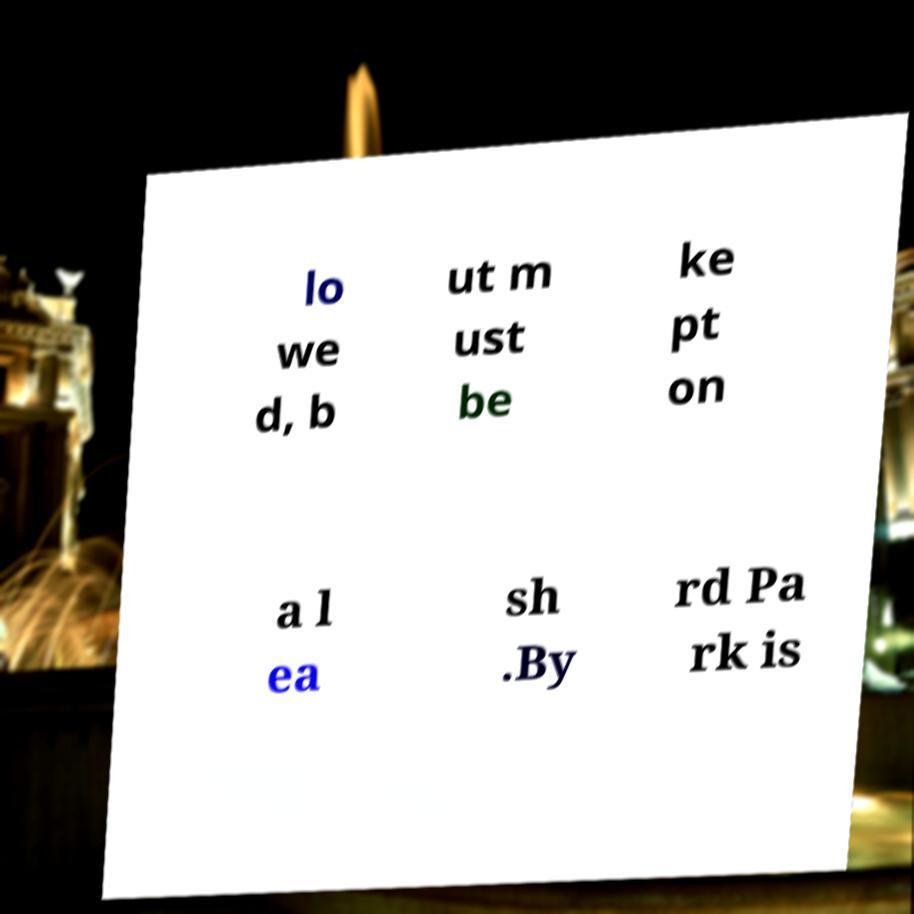What messages or text are displayed in this image? I need them in a readable, typed format. lo we d, b ut m ust be ke pt on a l ea sh .By rd Pa rk is 